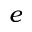Convert formula to latex. <formula><loc_0><loc_0><loc_500><loc_500>e</formula> 